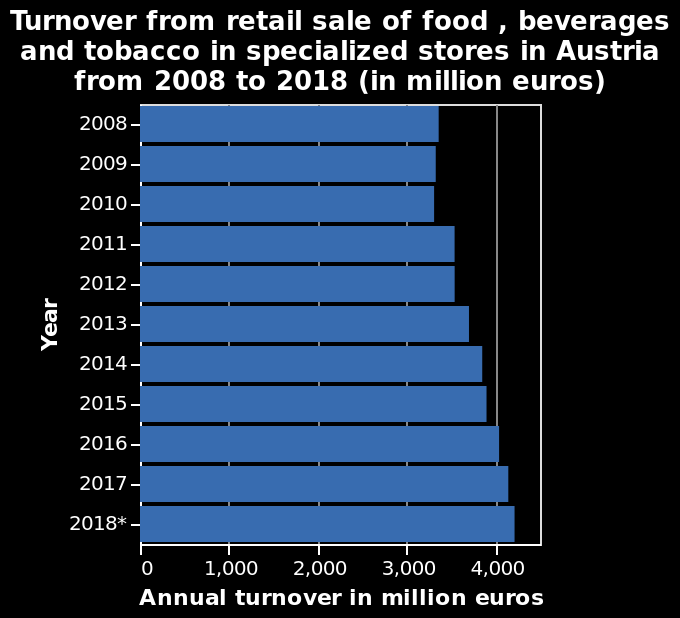<image>
What is the scale used for measuring turnover on the x-axis?  The x-axis uses a linear scale with a minimum of 0 and a maximum of 4,000 million euros. Since which year has turnover steadily increased? Turnover has steadily increased since 2010. please summary the statistics and relations of the chart Turnover fell very slightly between 2008 and 201o, but has steadily increased since then to 2018, the last year for which figures are available. Has turnover increased or decreased overall since 2008? Turnover has increased overall since 2008. 